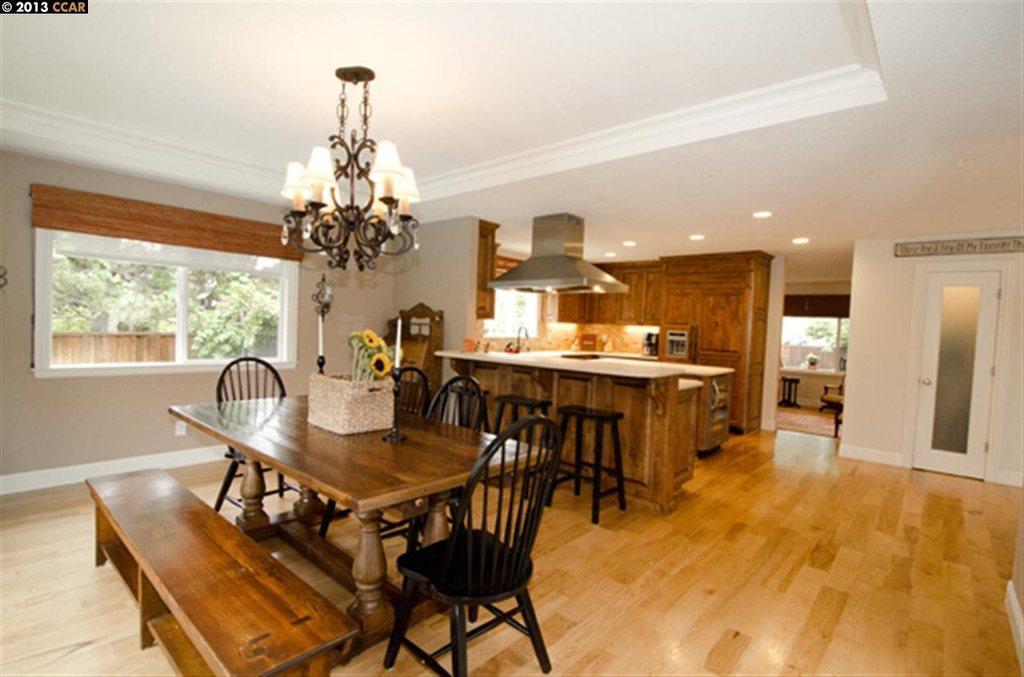How would you summarize this image in a sentence or two? In this picture there is a table and there are chairs around it, there is a flowers pot on the table, there is a bench in the image, there is a chandelier and chimney at the top side of the image, there is a desk in the image, there is a door on the right side of the image and there are windows in the image, there are trees outside the windows. 